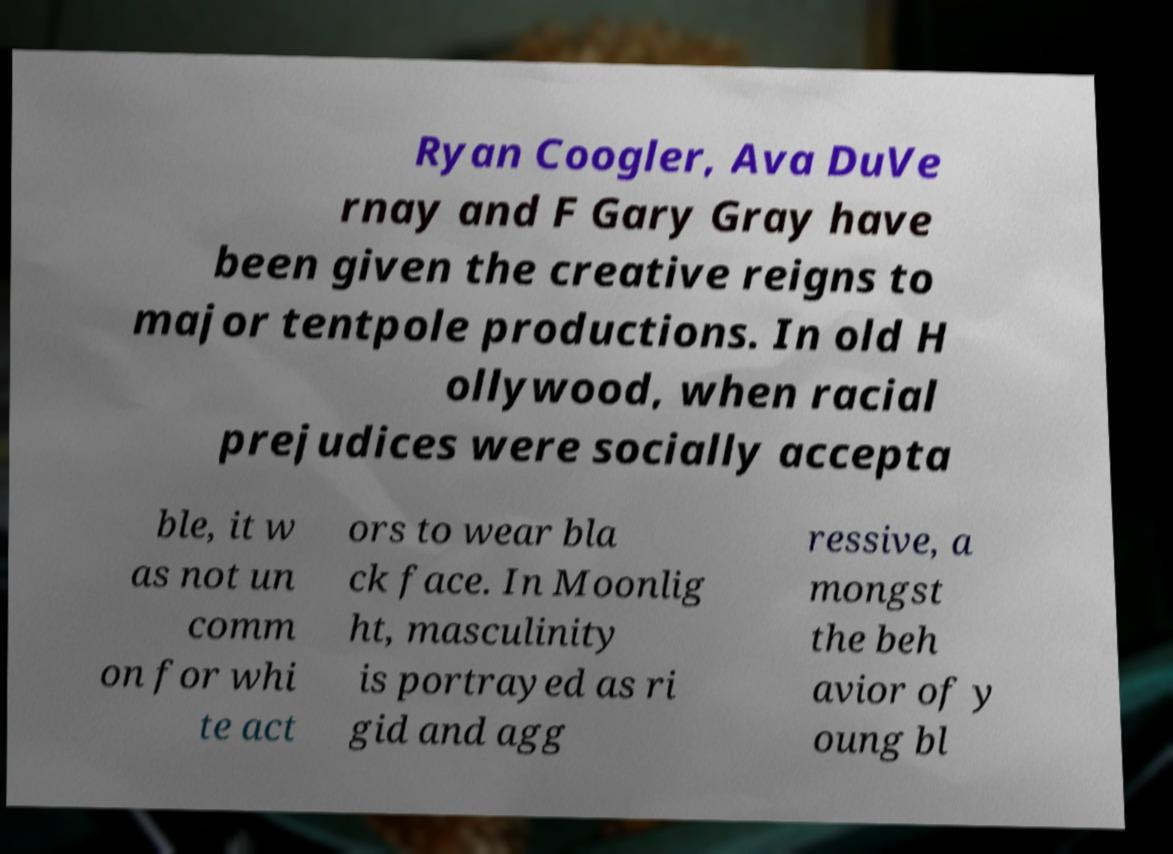Can you accurately transcribe the text from the provided image for me? Ryan Coogler, Ava DuVe rnay and F Gary Gray have been given the creative reigns to major tentpole productions. In old H ollywood, when racial prejudices were socially accepta ble, it w as not un comm on for whi te act ors to wear bla ck face. In Moonlig ht, masculinity is portrayed as ri gid and agg ressive, a mongst the beh avior of y oung bl 